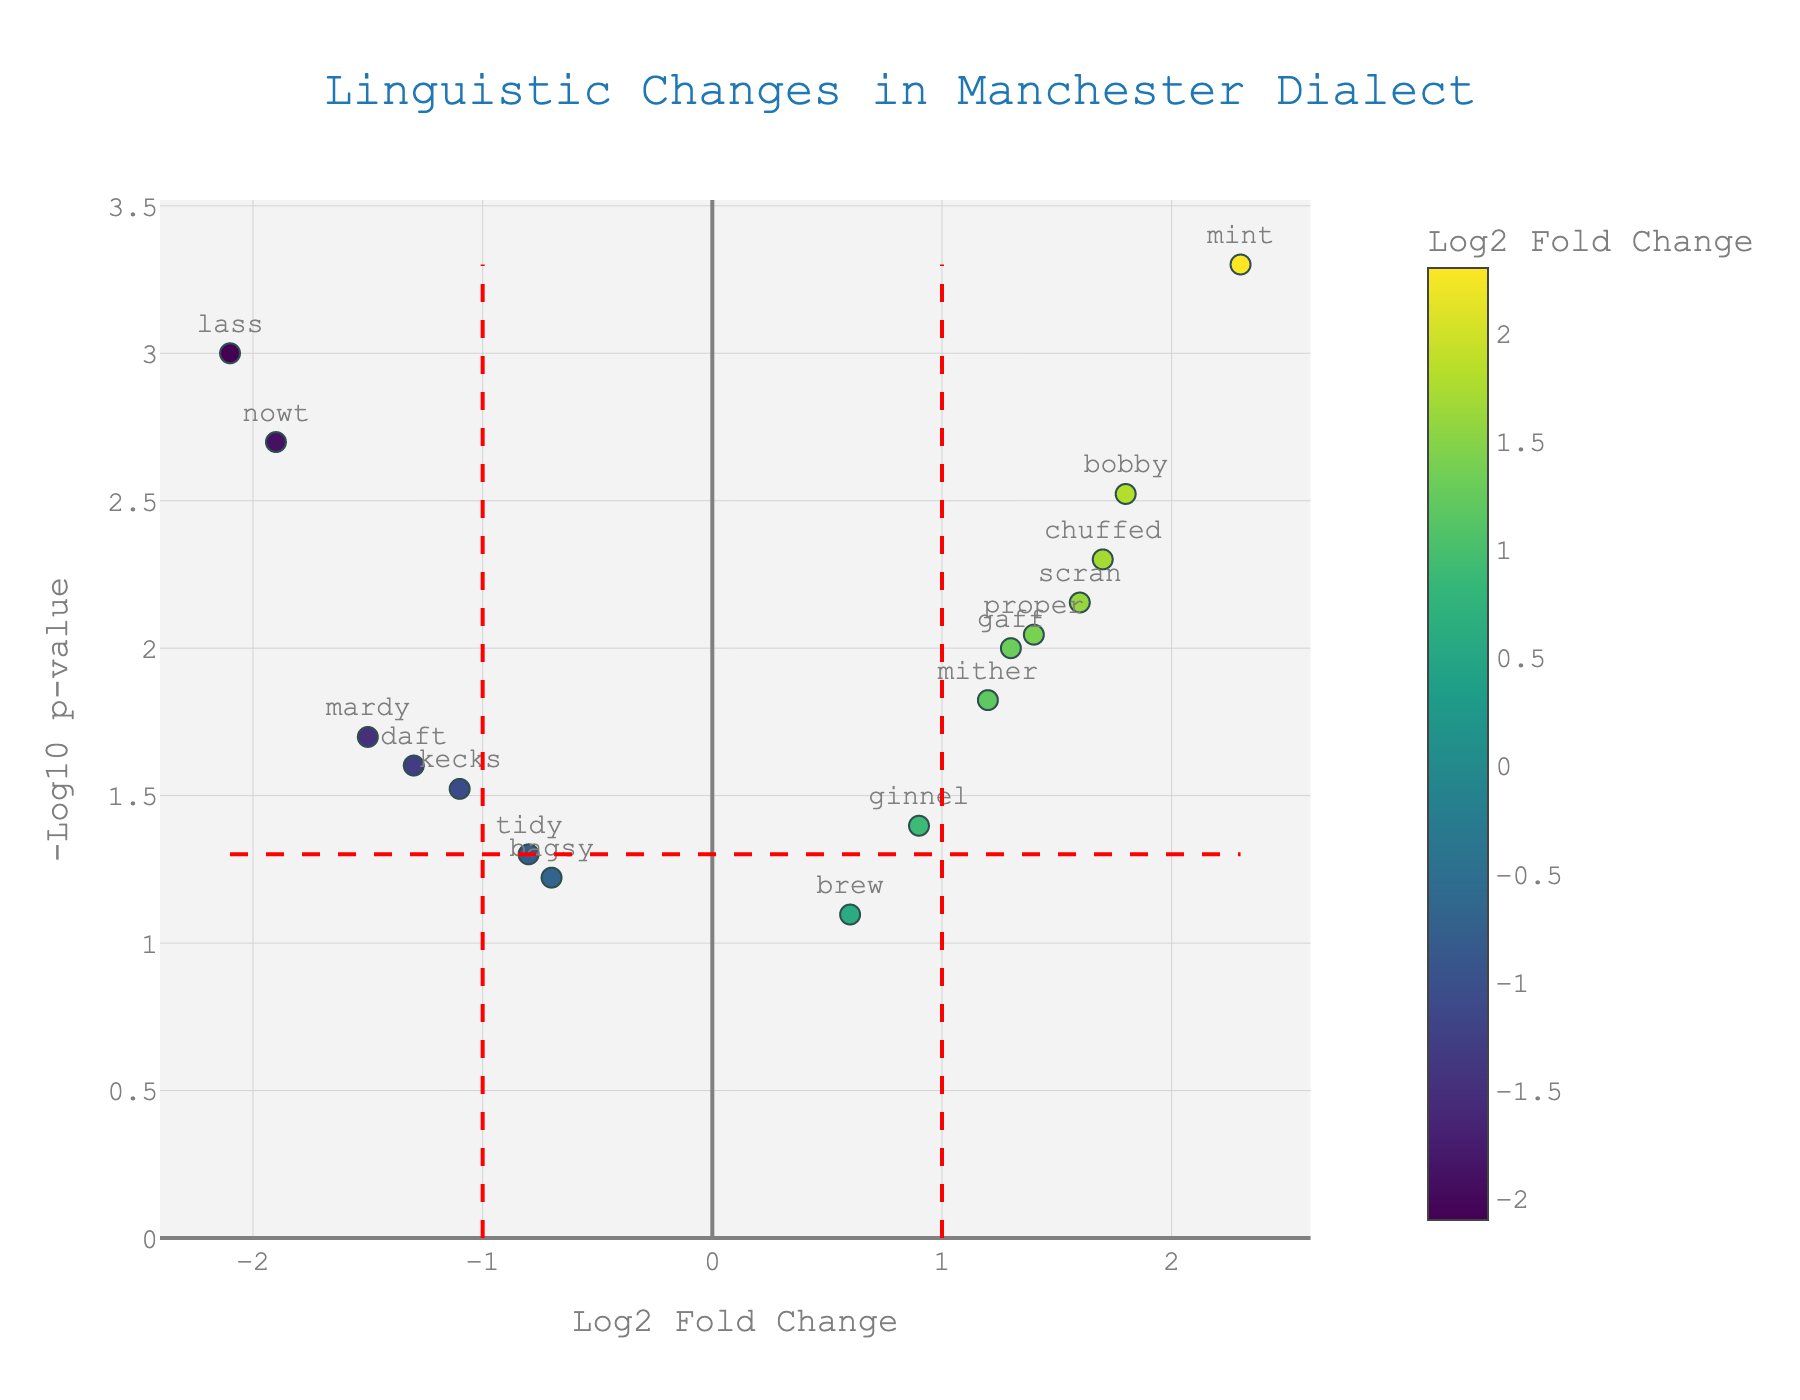what is the title of the plot? The title of the plot is displayed prominently at the top.
Answer: Linguistic Changes in Manchester Dialect What does the x-axis represent? The label at the bottom of the x-axis indicates what it represents.
Answer: Log2 Fold Change How many words have a positive log2 fold change above the threshold of 1? Count the words that appear to the right of the vertical dashed line at x=1.
Answer: 5 Which word has the highest log2 fold change? Identify the data point farthest to the right on the x-axis.
Answer: mint Which word has the smallest p-value? Locate the data point highest on the y-axis, as p-value is inversely represented by -log10(p).
Answer: mint Is "nowt" usage increasing or decreasing, and how significant is the change? The position of "nowt" is on the left side of the plot (negative log2 fold change) and high on the y-axis (small p-value), indicating a significant decrease in usage.
Answer: Decreasing, very significant Which word has a significant negative fold change but is closest to the threshold for p-value significance? Look for the word left of the vertical threshold and just above the horizontal threshold line on the y-axis.
Answer: mardy Which word has the most significant increase in usage with a p-value lower than 0.01? Identify words with a positive log2 fold change above the y=-log10(0.01) line. Then find the one with the highest fold change.
Answer: mint How many words have both a log2 fold change greater than 1 and a p-value less than 0.05? Count words that are found to the right of x=1 and above the horizontal threshold line.
Answer: 4 Compare the significance levels of "chuffed" and "kecks." Which has a more significant change in usage? Look at the y-values (representing -log10(p)) of both words and compare which is higher.
Answer: chuffed 